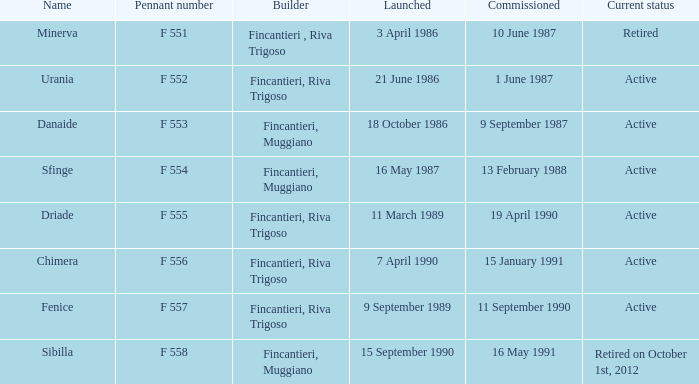What builder is now retired F 551. 